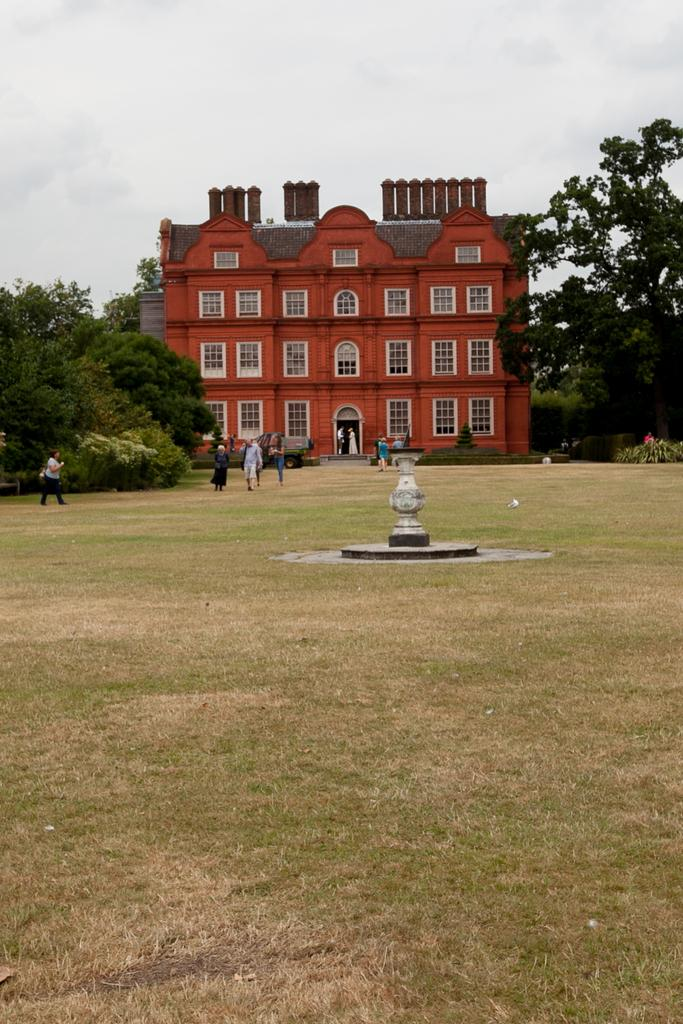What type of structure is visible in the image? There is a building with windows in the image. Who or what can be seen in the image besides the building? There are people and trees visible in the image. What feature can be found in the image that is not a building, person, or tree? There is a fountain in the image. What can be seen in the background of the image? The sky is visible in the background of the image. What type of vein is visible in the image? There is no vein present in the image. How many clovers can be seen in the image? There are no clovers present in the image. 